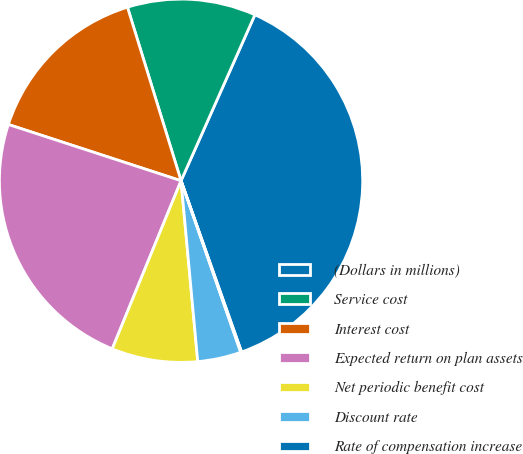Convert chart to OTSL. <chart><loc_0><loc_0><loc_500><loc_500><pie_chart><fcel>(Dollars in millions)<fcel>Service cost<fcel>Interest cost<fcel>Expected return on plan assets<fcel>Net periodic benefit cost<fcel>Discount rate<fcel>Rate of compensation increase<nl><fcel>37.93%<fcel>11.43%<fcel>15.22%<fcel>23.83%<fcel>7.65%<fcel>3.86%<fcel>0.08%<nl></chart> 